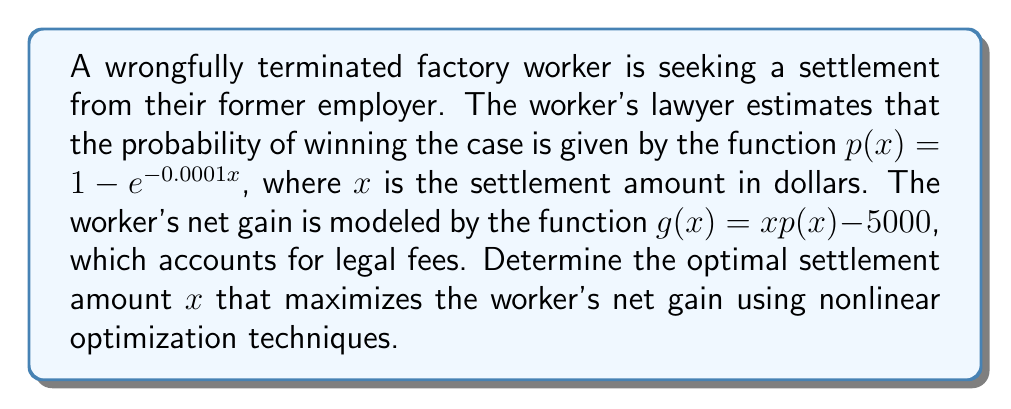Can you answer this question? To find the optimal settlement amount, we need to maximize the net gain function $g(x)$. We'll use calculus to find the maximum of this nonlinear function.

1) First, let's expand the net gain function:
   $g(x) = x(1 - e^{-0.0001x}) - 5000$

2) To find the maximum, we need to find where the derivative of $g(x)$ equals zero:
   $\frac{dg}{dx} = (1 - e^{-0.0001x}) + x(0.0001e^{-0.0001x}) - 0 = 0$

3) Simplify the equation:
   $1 - e^{-0.0001x} + 0.0001xe^{-0.0001x} = 0$

4) This equation can't be solved algebraically, so we need to use numerical methods. Using a computer algebra system or numerical solver, we find that the solution is approximately:
   $x \approx 13,813.67$

5) To confirm this is a maximum, we can check the second derivative:
   $\frac{d^2g}{dx^2} = 0.0002e^{-0.0001x} - 0.00000001xe^{-0.0001x}$

   At $x = 13,813.67$, this is negative, confirming a maximum.

6) The optimal settlement amount is therefore approximately $13,814 (rounded to the nearest dollar).
Answer: $13,814 